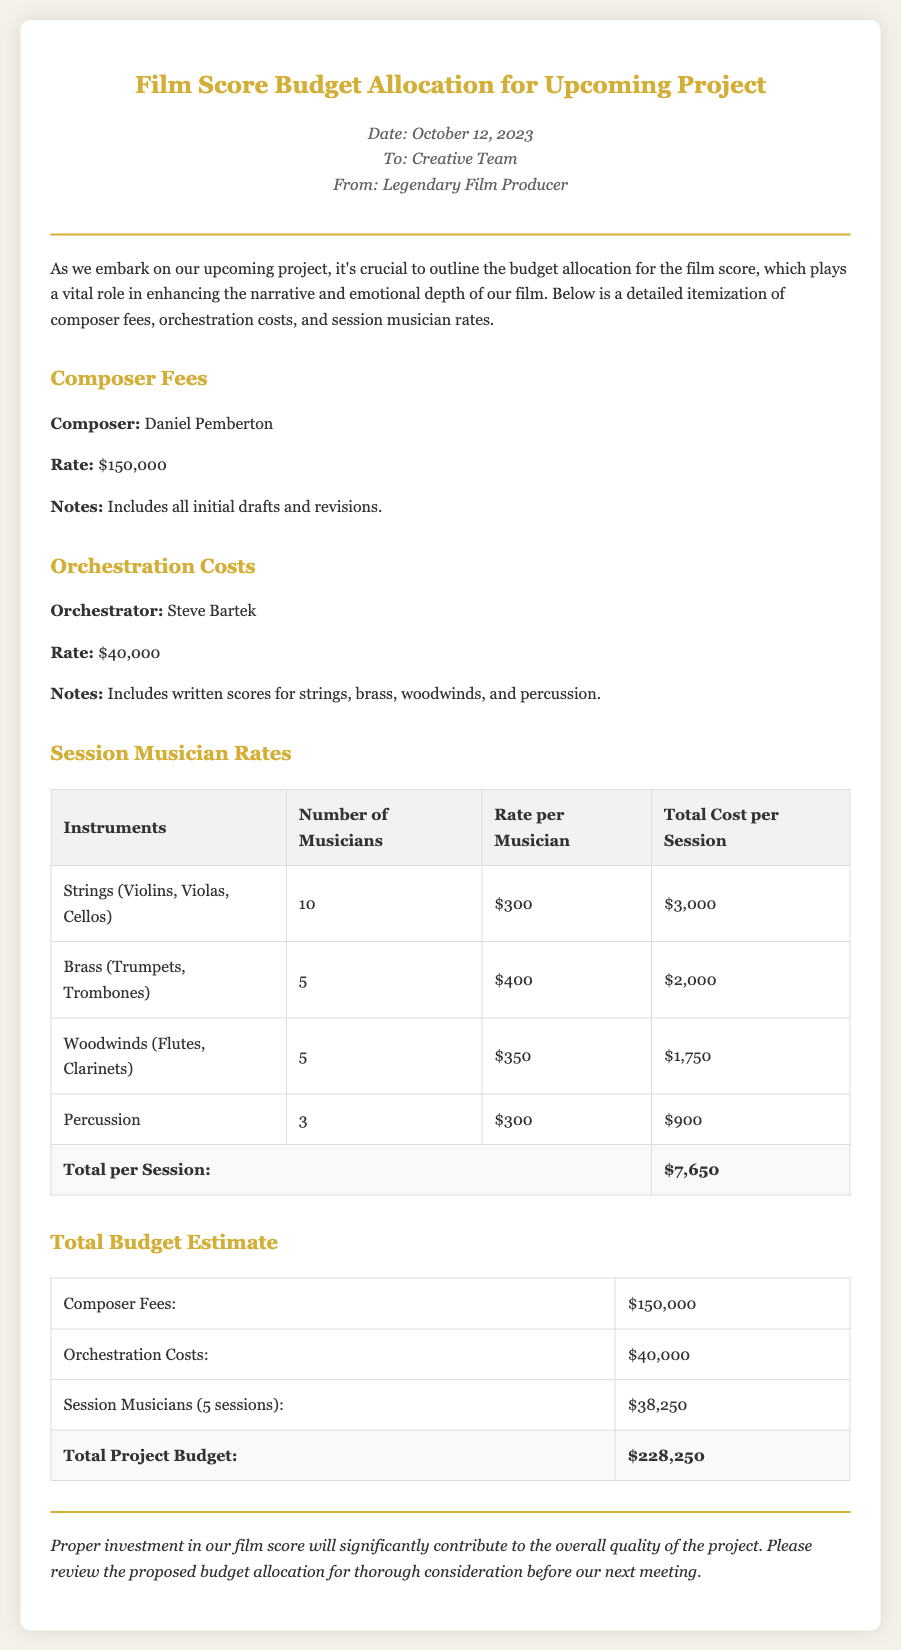what is the composer's name? The composer's name is mentioned under the Composer Fees section as Daniel Pemberton.
Answer: Daniel Pemberton how much is the orchestration cost? The orchestration cost is stated in the Orchestration Costs section as $40,000.
Answer: $40,000 how many string musicians are required? The number of string musicians is specified in the Session Musician Rates table as 10.
Answer: 10 what is the total cost per session for strings? The total cost per session for strings is calculated in the Session Musician Rates table, which is $3,000.
Answer: $3,000 what is the total project budget? The total project budget is the final sum provided in the Total Budget Estimate table, which is $228,250.
Answer: $228,250 who is the orchestrator? The orchestrator is mentioned under the Orchestration Costs section as Steve Bartek.
Answer: Steve Bartek how many sessions of musicians are accounted for in the budget? The document mentions that there are 5 sessions of musicians included in the budget estimate.
Answer: 5 sessions what is the rate per musician for brass instruments? The rate per musician for brass instruments is specified in the Session Musician Rates table as $400.
Answer: $400 what is the date of the memo? The date of the memo is provided in the header as October 12, 2023.
Answer: October 12, 2023 